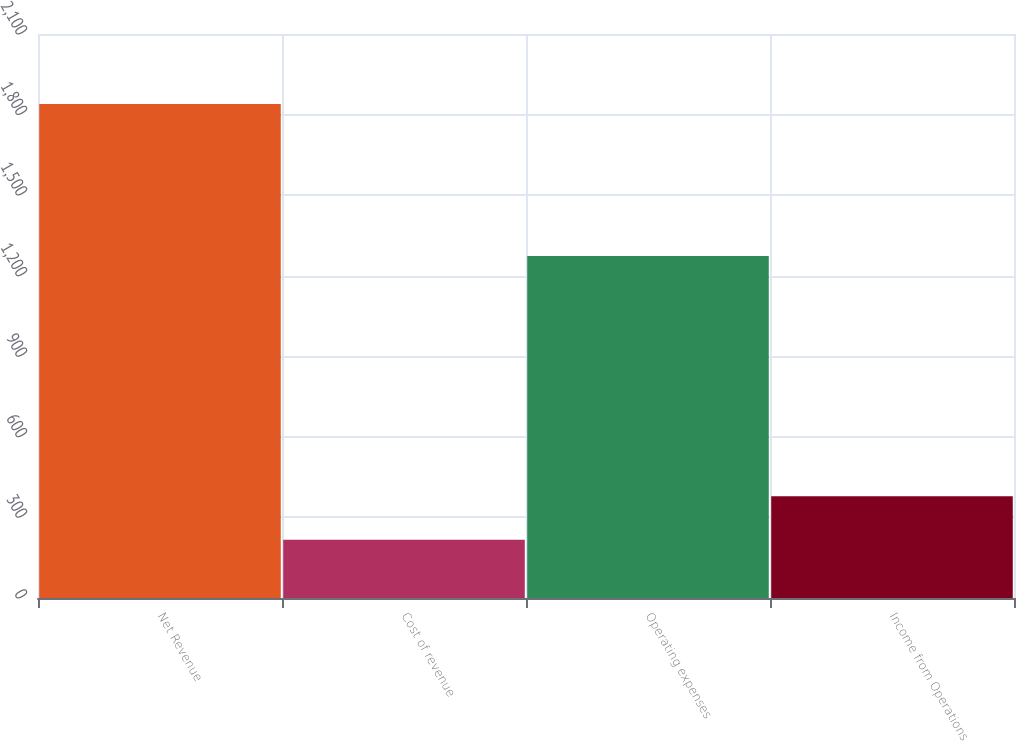Convert chart to OTSL. <chart><loc_0><loc_0><loc_500><loc_500><bar_chart><fcel>Net Revenue<fcel>Cost of revenue<fcel>Operating expenses<fcel>Income from Operations<nl><fcel>1839.8<fcel>216.6<fcel>1273.5<fcel>378.92<nl></chart> 